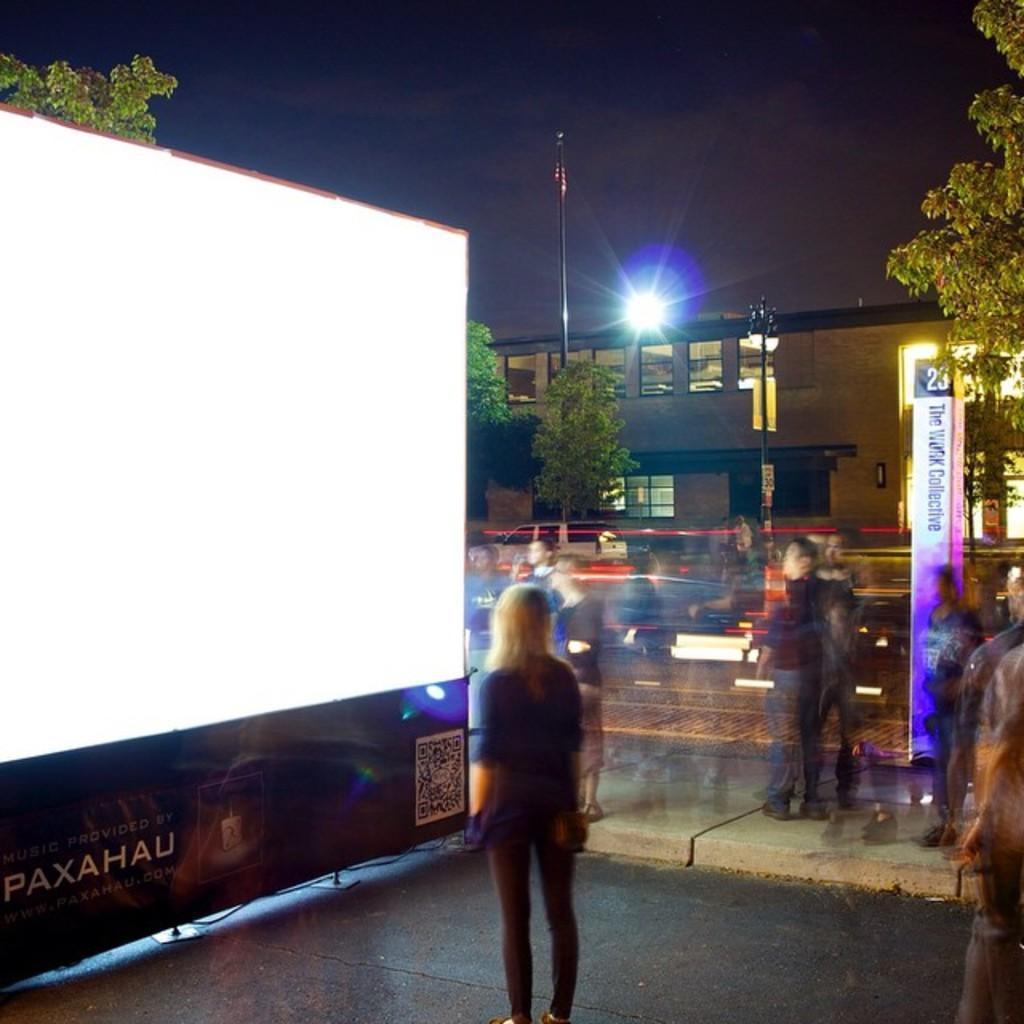Describe this image in one or two sentences. In this image a few persons are standing in front of a digital screen and watch it, there are few trees, a street light, a building, a flag pole and a flag in the image. 